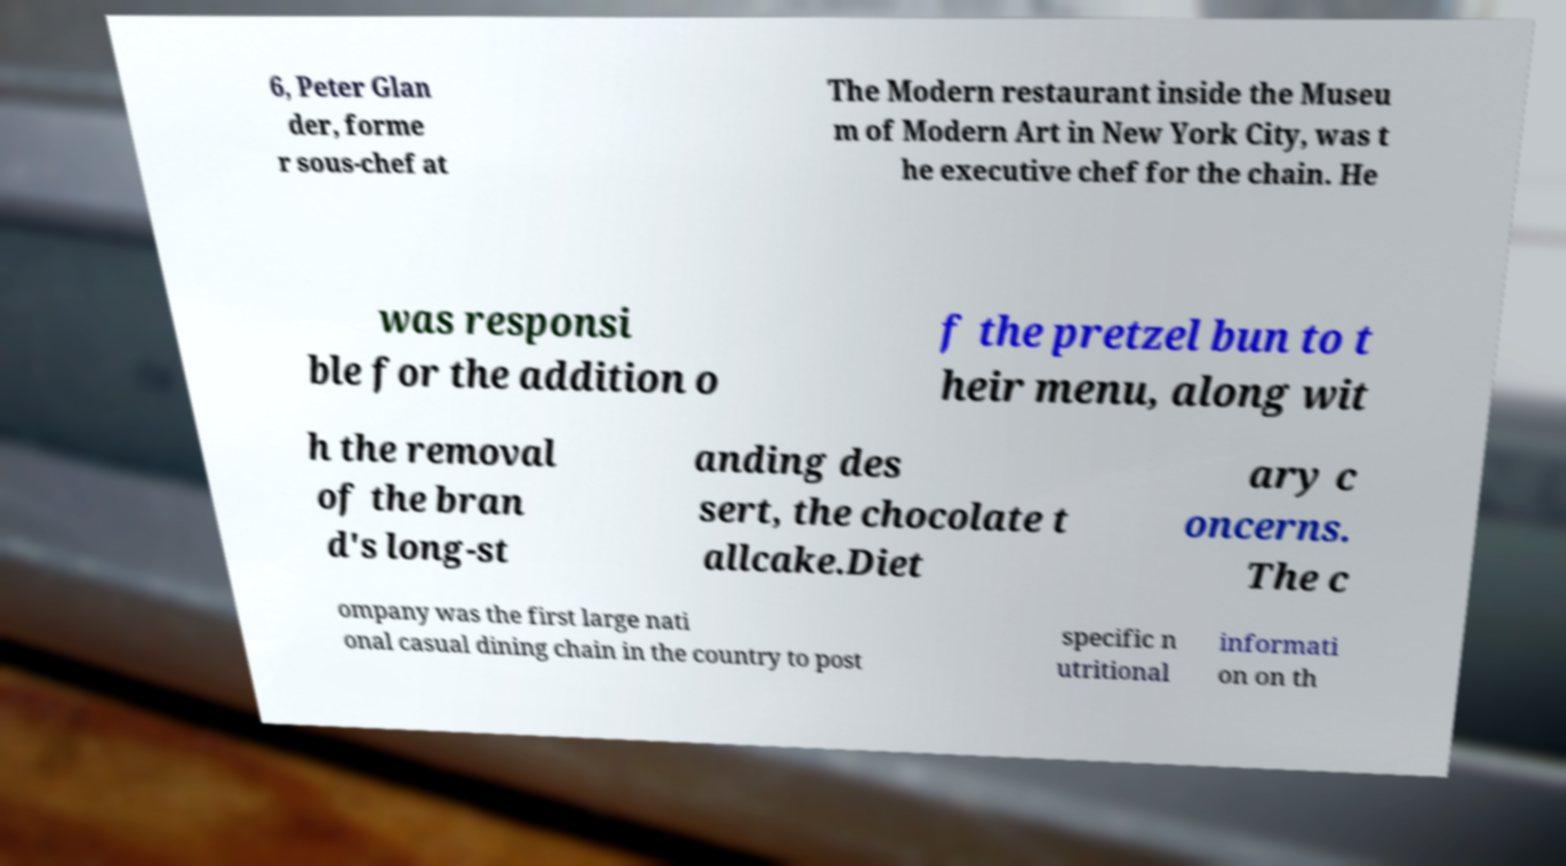There's text embedded in this image that I need extracted. Can you transcribe it verbatim? 6, Peter Glan der, forme r sous-chef at The Modern restaurant inside the Museu m of Modern Art in New York City, was t he executive chef for the chain. He was responsi ble for the addition o f the pretzel bun to t heir menu, along wit h the removal of the bran d's long-st anding des sert, the chocolate t allcake.Diet ary c oncerns. The c ompany was the first large nati onal casual dining chain in the country to post specific n utritional informati on on th 